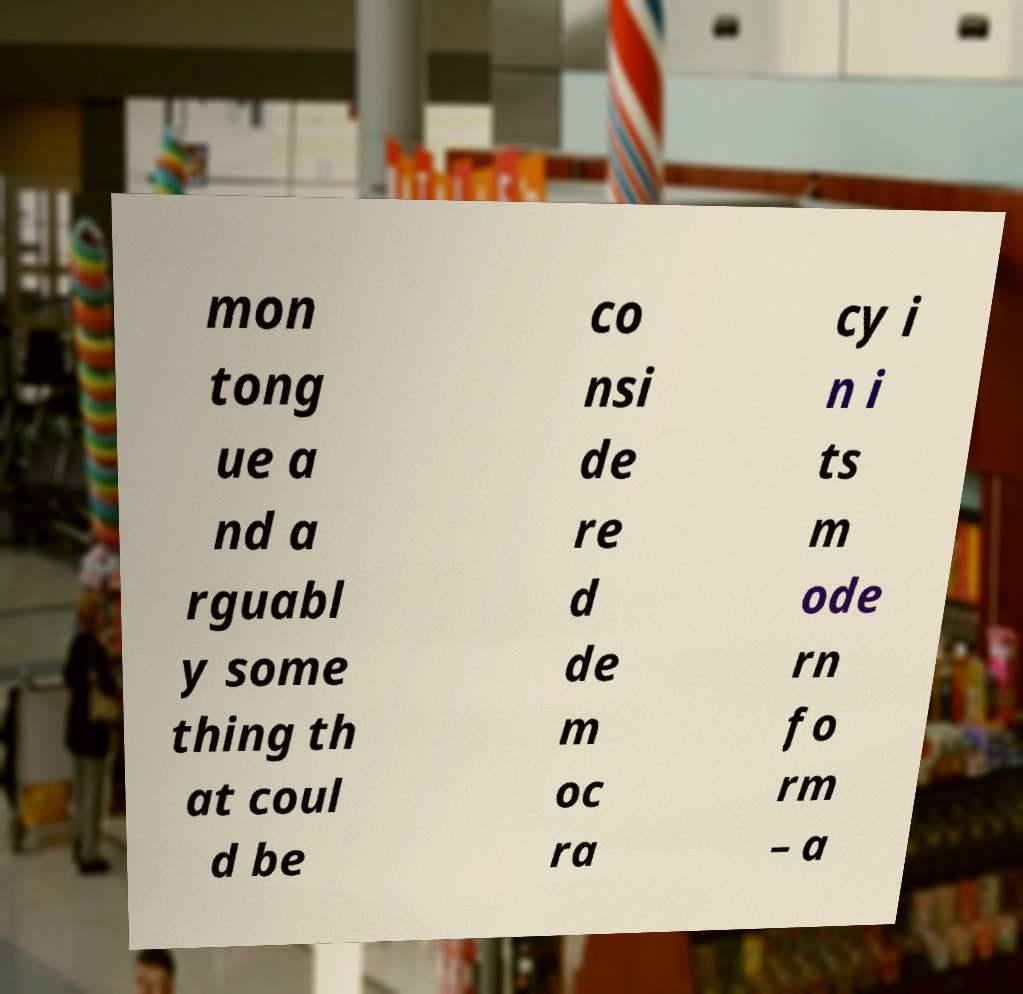For documentation purposes, I need the text within this image transcribed. Could you provide that? mon tong ue a nd a rguabl y some thing th at coul d be co nsi de re d de m oc ra cy i n i ts m ode rn fo rm – a 